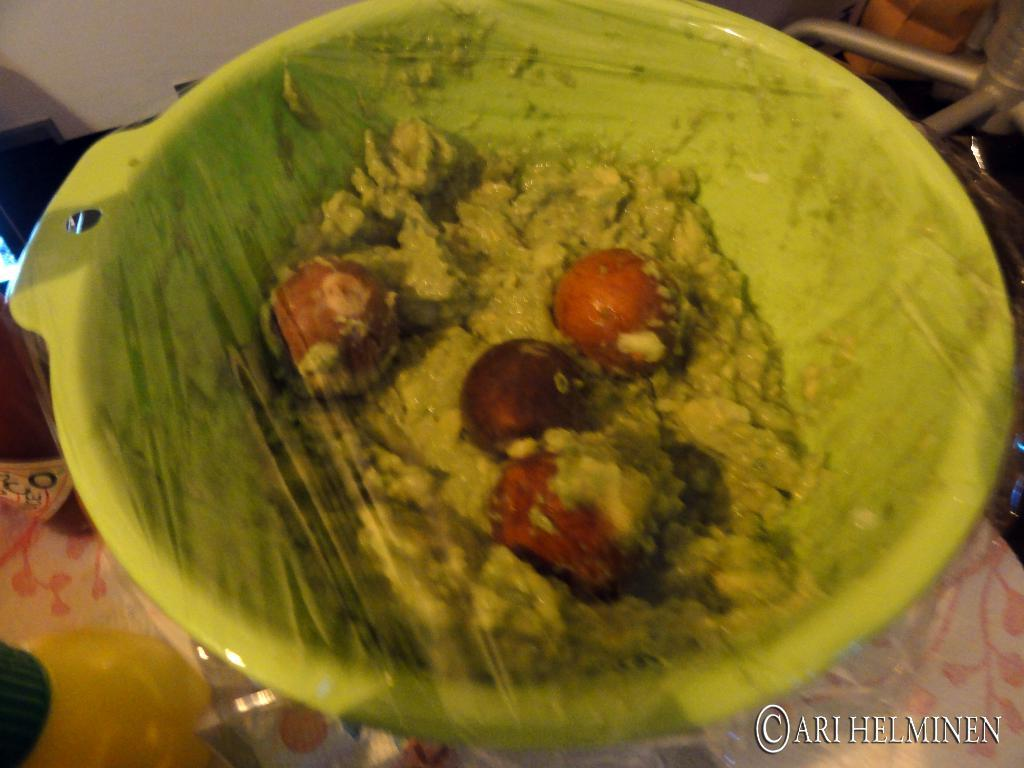What is in the bowl that is visible in the image? There is a food item in a bowl in the image. Can you describe the food item in the bowl? The food item is packed. What else can be seen around the bowl in the image? There are a few objects around the bowl in the image. How does the food item in the bowl participate in a game of volleyball in the image? The food item in the bowl does not participate in a game of volleyball in the image, as there is no mention of volleyball or any related activity in the provided facts. 